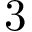Convert formula to latex. <formula><loc_0><loc_0><loc_500><loc_500>3</formula> 